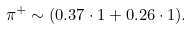<formula> <loc_0><loc_0><loc_500><loc_500>\pi ^ { + } \sim ( 0 . 3 7 \cdot 1 + 0 . 2 6 \cdot 1 ) .</formula> 